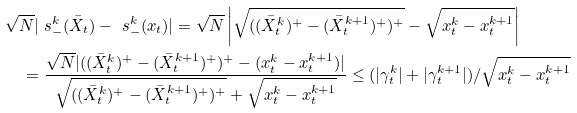Convert formula to latex. <formula><loc_0><loc_0><loc_500><loc_500>& \sqrt { N } | \ s _ { - } ^ { k } ( \bar { X } _ { t } ) - \ s _ { - } ^ { k } ( x _ { t } ) | = \sqrt { N } \left | \sqrt { ( ( \bar { X } _ { t } ^ { k } ) ^ { + } - ( \bar { X } _ { t } ^ { k + 1 } ) ^ { + } ) ^ { + } } - \sqrt { x _ { t } ^ { k } - x _ { t } ^ { k + 1 } } \right | \\ & \quad = \frac { \sqrt { N } | ( ( \bar { X } _ { t } ^ { k } ) ^ { + } - ( \bar { X } _ { t } ^ { k + 1 } ) ^ { + } ) ^ { + } - ( x _ { t } ^ { k } - x _ { t } ^ { k + 1 } ) | } { \sqrt { ( ( \bar { X } _ { t } ^ { k } ) ^ { + } - ( \bar { X } _ { t } ^ { k + 1 } ) ^ { + } ) ^ { + } } + \sqrt { x _ { t } ^ { k } - x _ { t } ^ { k + 1 } } } \leq ( | \gamma _ { t } ^ { k } | + | \gamma _ { t } ^ { k + 1 } | ) / \sqrt { x _ { t } ^ { k } - x _ { t } ^ { k + 1 } }</formula> 